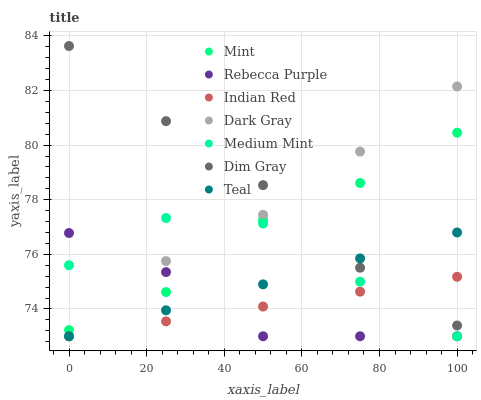Does Rebecca Purple have the minimum area under the curve?
Answer yes or no. Yes. Does Dim Gray have the maximum area under the curve?
Answer yes or no. Yes. Does Teal have the minimum area under the curve?
Answer yes or no. No. Does Teal have the maximum area under the curve?
Answer yes or no. No. Is Teal the smoothest?
Answer yes or no. Yes. Is Medium Mint the roughest?
Answer yes or no. Yes. Is Dim Gray the smoothest?
Answer yes or no. No. Is Dim Gray the roughest?
Answer yes or no. No. Does Medium Mint have the lowest value?
Answer yes or no. Yes. Does Dim Gray have the lowest value?
Answer yes or no. No. Does Dim Gray have the highest value?
Answer yes or no. Yes. Does Teal have the highest value?
Answer yes or no. No. Is Indian Red less than Mint?
Answer yes or no. Yes. Is Mint greater than Indian Red?
Answer yes or no. Yes. Does Dim Gray intersect Dark Gray?
Answer yes or no. Yes. Is Dim Gray less than Dark Gray?
Answer yes or no. No. Is Dim Gray greater than Dark Gray?
Answer yes or no. No. Does Indian Red intersect Mint?
Answer yes or no. No. 